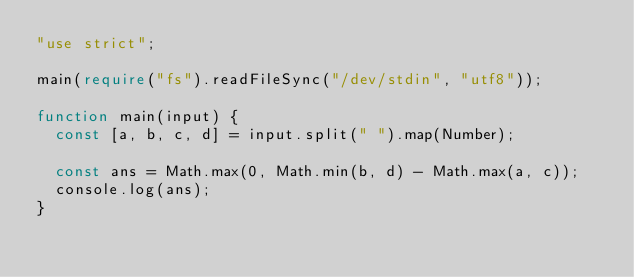Convert code to text. <code><loc_0><loc_0><loc_500><loc_500><_TypeScript_>"use strict";

main(require("fs").readFileSync("/dev/stdin", "utf8"));

function main(input) {
  const [a, b, c, d] = input.split(" ").map(Number);

  const ans = Math.max(0, Math.min(b, d) - Math.max(a, c));
  console.log(ans);
}</code> 